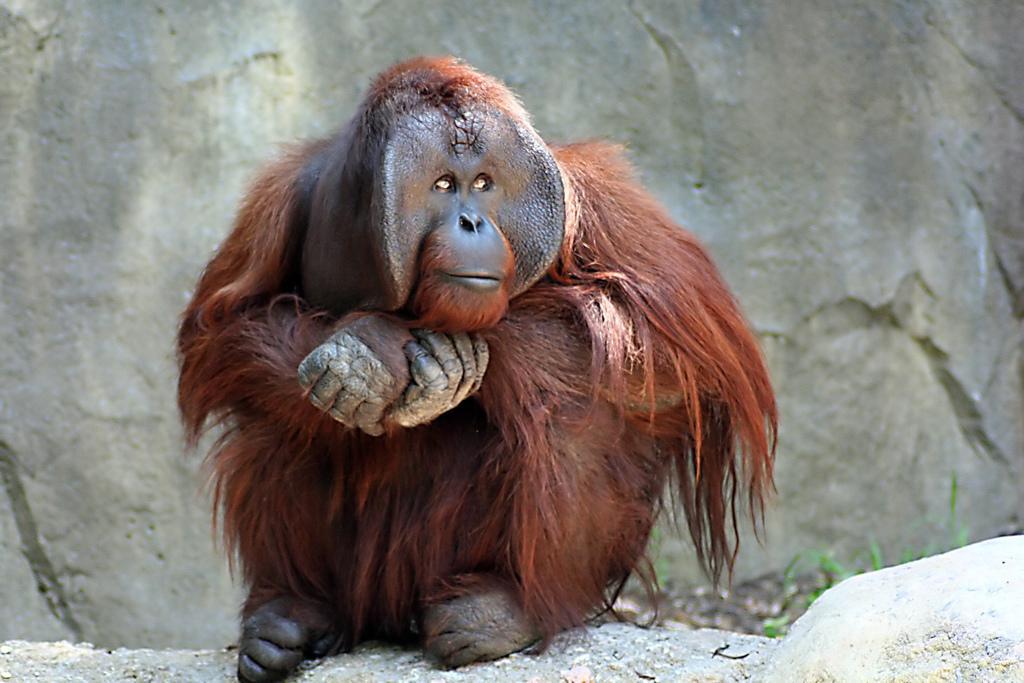Could you give a brief overview of what you see in this image? In this image I can see an orangutan which is siting on the ground. In the background I can see the grass. 